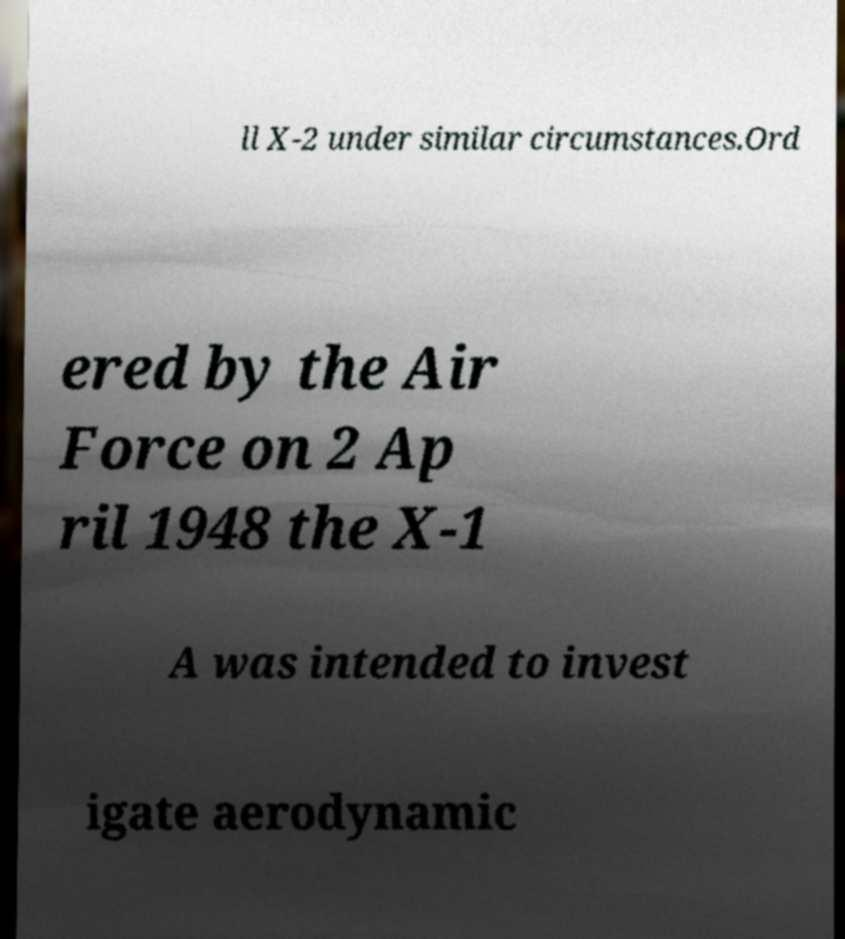Please identify and transcribe the text found in this image. ll X-2 under similar circumstances.Ord ered by the Air Force on 2 Ap ril 1948 the X-1 A was intended to invest igate aerodynamic 